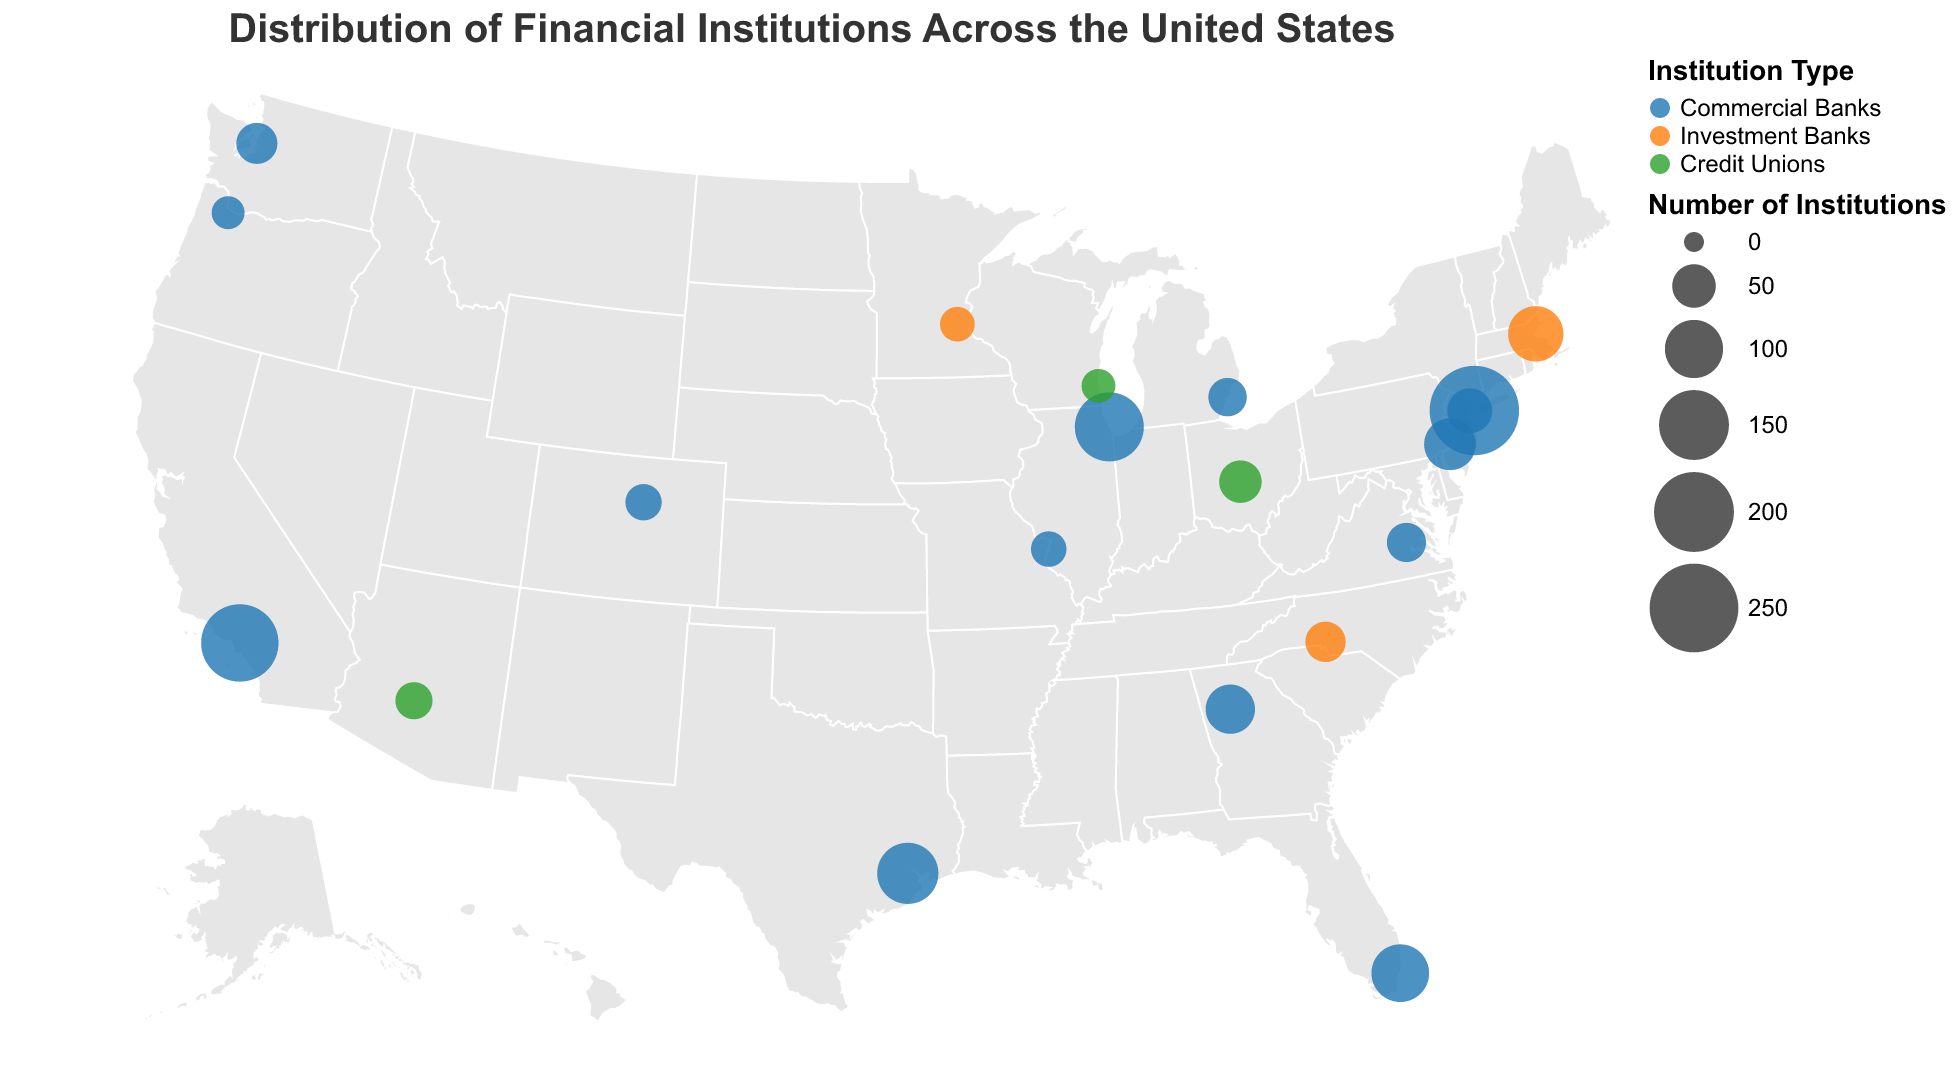What's the title of the plot? The title is displayed at the top of the plot and it reads "Distribution of Financial Institutions Across the United States".
Answer: Distribution of Financial Institutions Across the United States Which city has the highest concentration of financial institutions? By looking at the size of the circles representing financial institutions, New York City has the largest circle, indicating the highest concentration with 254 institutions.
Answer: New York City What type of institutions are most common in Philadelphia? Looking at the color legend, which shows Commercial Banks with a particular color, Philadelphia's circle is this color, indicating the most common type is Commercial Banks.
Answer: Commercial Banks How does the number of institutions in Boston compare to Seattle? The tooltip for Boston shows 89 institutions and Seattle shows 43. Boston has more institutions than Seattle.
Answer: Boston has more institutions What's the combined number of financial institutions in Houston and Miami? Houston has 112 institutions, and Miami has 98. Adding them together gives 112 + 98 = 210.
Answer: 210 Identify the city with the second highest number of financial institutions? Los Angeles has the second largest circle, indicating it has the second highest number with 187 institutions.
Answer: Los Angeles Which cities have Investment Banks as the primary type of institutions? Among the circles colored for Investment Banks, Boston, Charlotte, and Minneapolis are highlighted as having Investment Banks as their primary type.
Answer: Boston, Charlotte, Minneapolis What is the difference in the number of banks between Atlanta and Chicago? Chicago has 146 institutions, while Atlanta has 68. The difference is 146 - 68 = 78.
Answer: 78 What is the median number of institutions for all cities listed? Ordering the institutions counts: 23, 25, 27, 29, 31, 33, 36, 38, 41, 43, 47, 54, 68, 76, 89, 98, 112, 146, 187, 254, the middle numbers (41 and 43) give a median of (41+43)/2 = 42.
Answer: 42 Which state has the fewest financial institutions in the listed cities? Looking at the smallest circles, Oregon (Portland) has the fewest with 23 institutions.
Answer: Oregon 